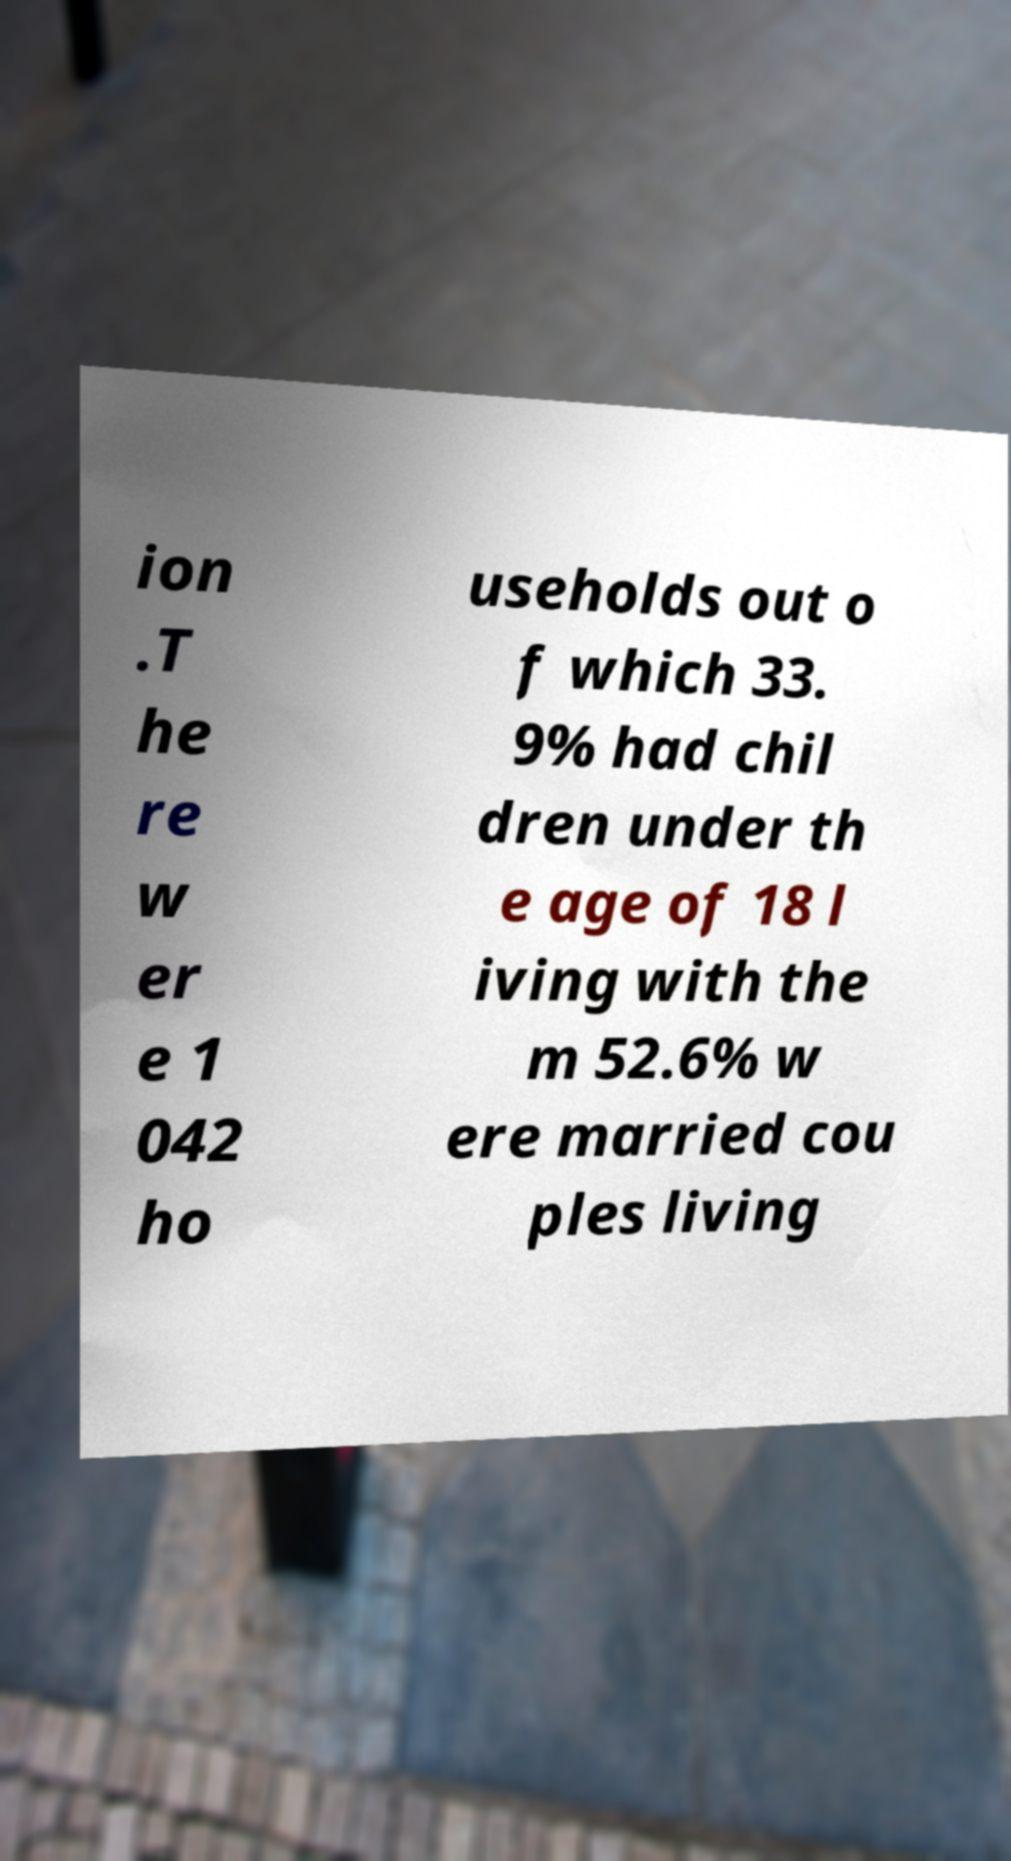What messages or text are displayed in this image? I need them in a readable, typed format. ion .T he re w er e 1 042 ho useholds out o f which 33. 9% had chil dren under th e age of 18 l iving with the m 52.6% w ere married cou ples living 